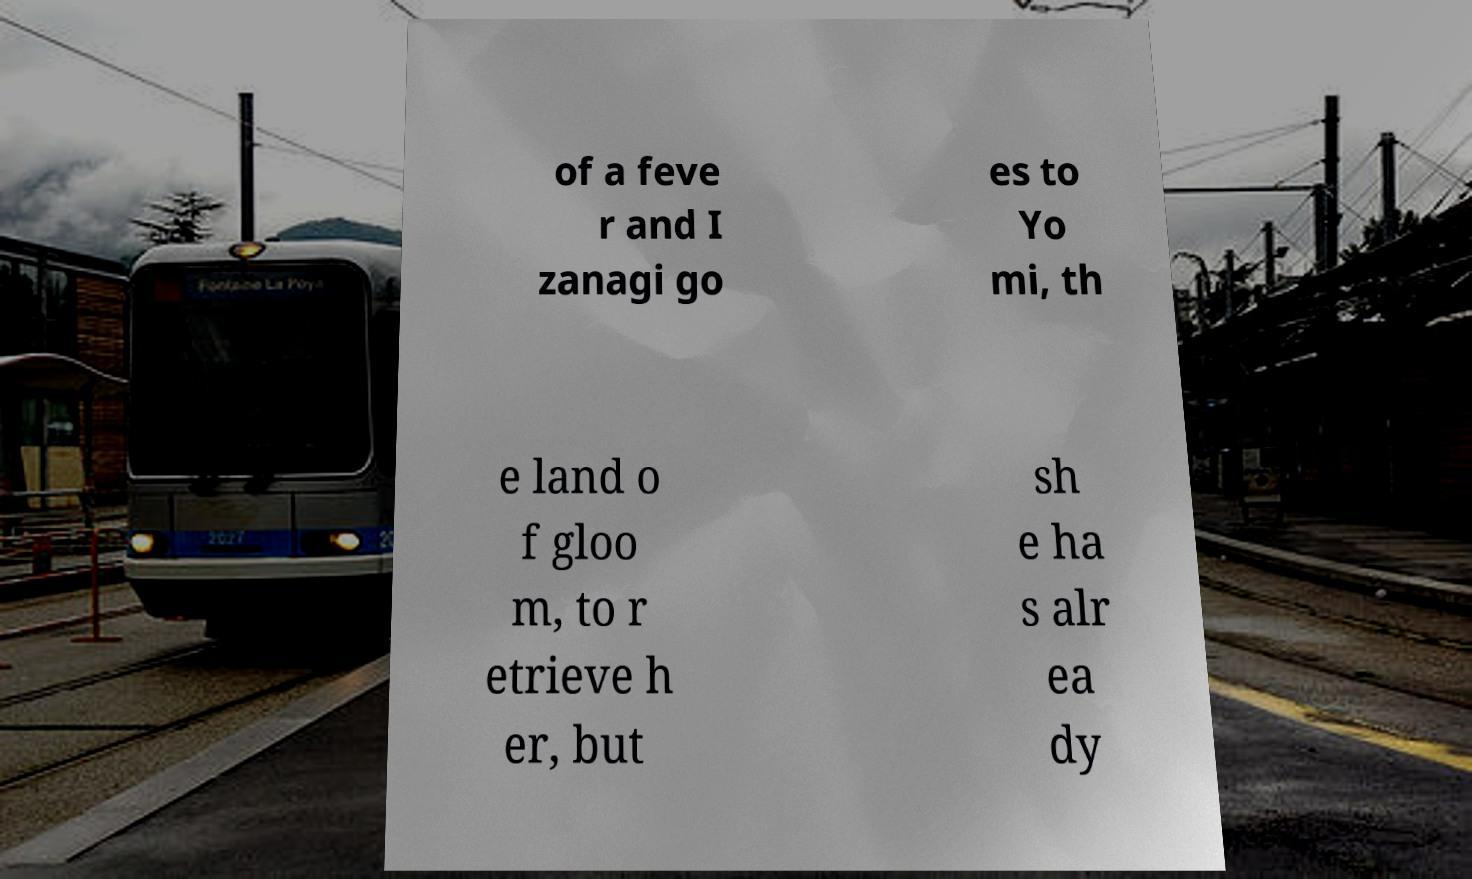Can you accurately transcribe the text from the provided image for me? of a feve r and I zanagi go es to Yo mi, th e land o f gloo m, to r etrieve h er, but sh e ha s alr ea dy 